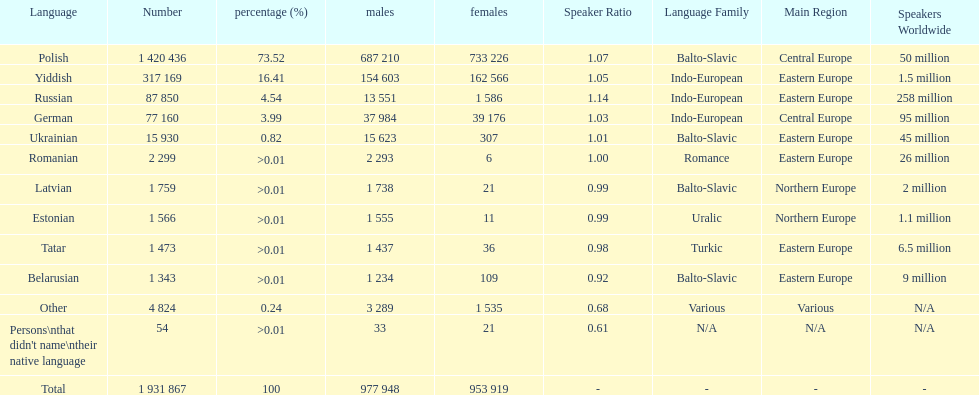Is german above or below russia in the number of people who speak that language? Below. 